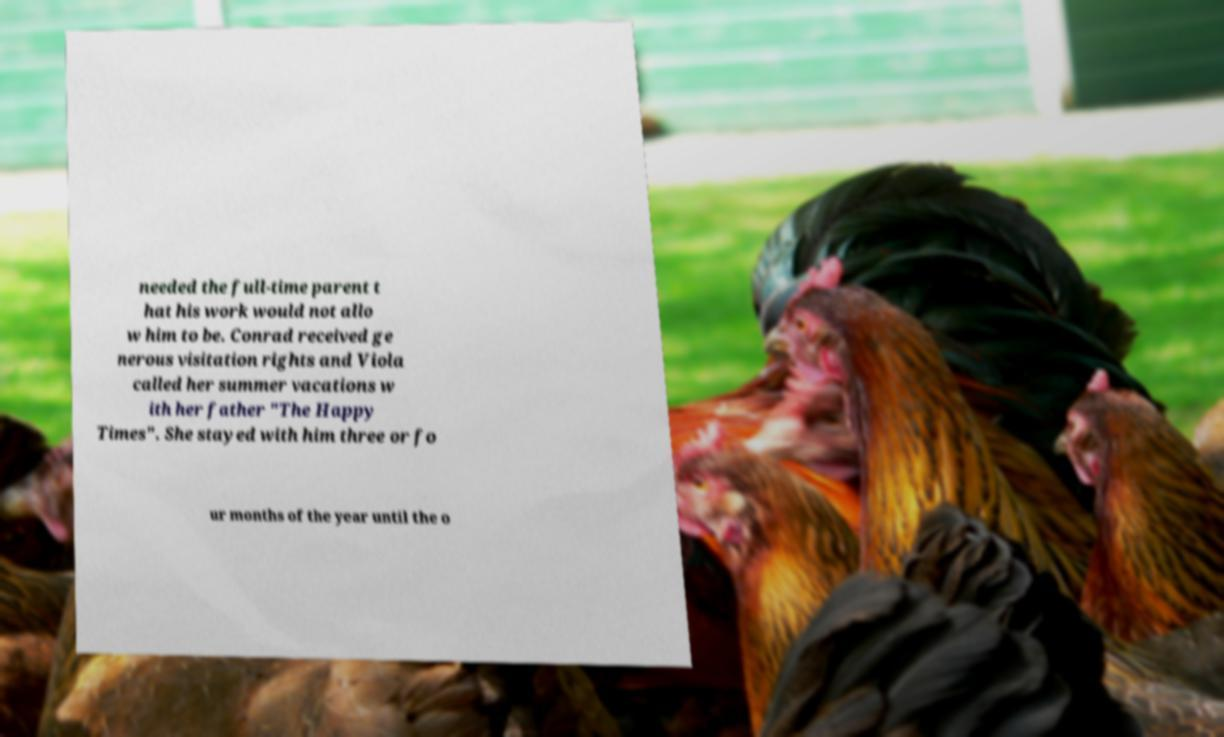Could you assist in decoding the text presented in this image and type it out clearly? needed the full-time parent t hat his work would not allo w him to be. Conrad received ge nerous visitation rights and Viola called her summer vacations w ith her father "The Happy Times". She stayed with him three or fo ur months of the year until the o 